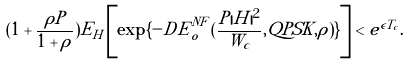Convert formula to latex. <formula><loc_0><loc_0><loc_500><loc_500>( 1 + \frac { \rho P } { 1 + \rho } ) E _ { H } \left [ \exp \{ - D { \tilde { E } } _ { o } ^ { N F } ( \frac { P | H | ^ { 2 } } { W _ { c } } , Q P S K , \rho ) \} \right ] < e ^ { \epsilon T _ { c } } .</formula> 